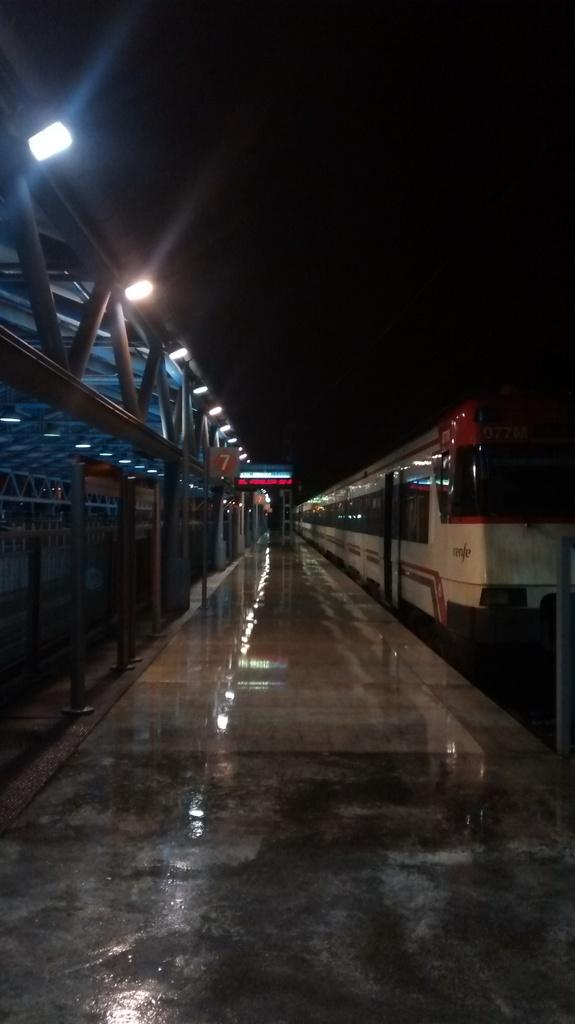What is the main subject of the image? The main subject of the image is a train. What colors are used to paint the train? The train is white and red in color. What other objects can be seen in the image besides the train? Boards and lights are visible in the image. How would you describe the overall lighting in the image? The background of the image is dark. What type of plant is being watered by the secretary in the image? There is no secretary or plant present in the image; it features a train with boards and lights. 